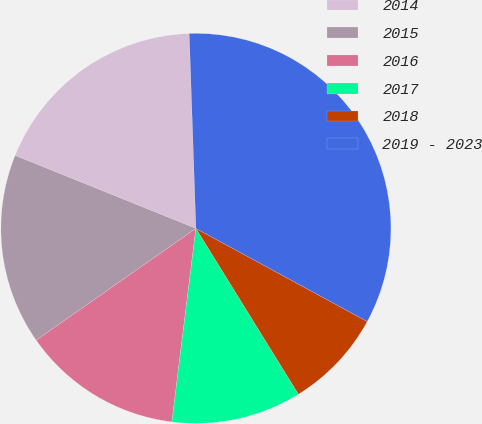Convert chart to OTSL. <chart><loc_0><loc_0><loc_500><loc_500><pie_chart><fcel>2014<fcel>2015<fcel>2016<fcel>2017<fcel>2018<fcel>2019 - 2023<nl><fcel>18.35%<fcel>15.83%<fcel>13.31%<fcel>10.78%<fcel>8.26%<fcel>33.47%<nl></chart> 